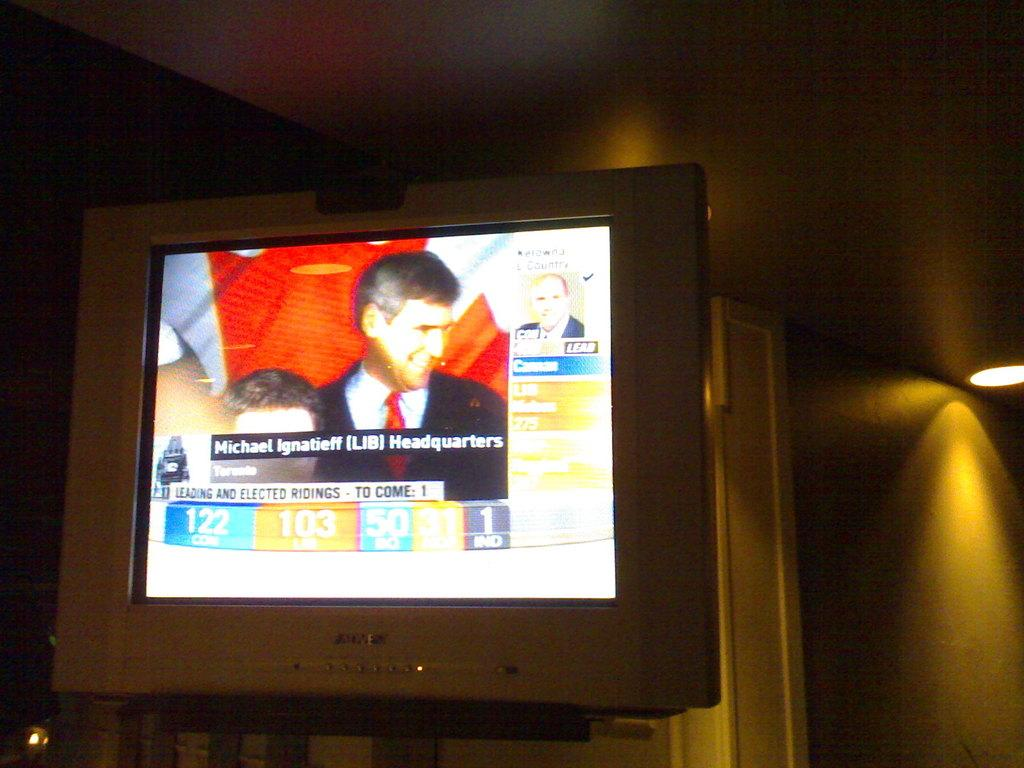What is attached to the wall in the image? There is a screen attached to the wall in the image. What is attached to the roof on the right side of the image? There is a light attached to the roof on the right side of the image. What can be seen on the screen? The screen displays images of people and text. What type of spark can be seen in the sky in the image? There is no spark or sky present in the image; it only features a screen and a light. 